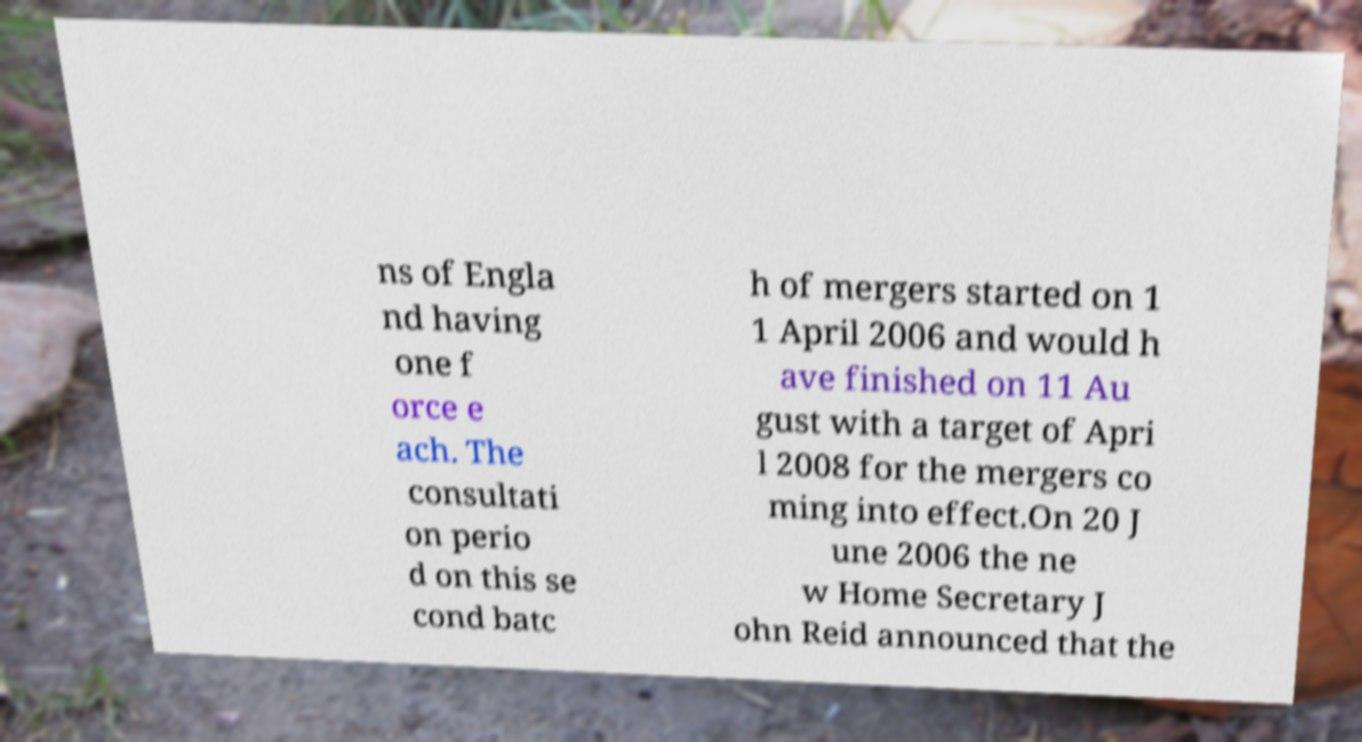Could you assist in decoding the text presented in this image and type it out clearly? ns of Engla nd having one f orce e ach. The consultati on perio d on this se cond batc h of mergers started on 1 1 April 2006 and would h ave finished on 11 Au gust with a target of Apri l 2008 for the mergers co ming into effect.On 20 J une 2006 the ne w Home Secretary J ohn Reid announced that the 